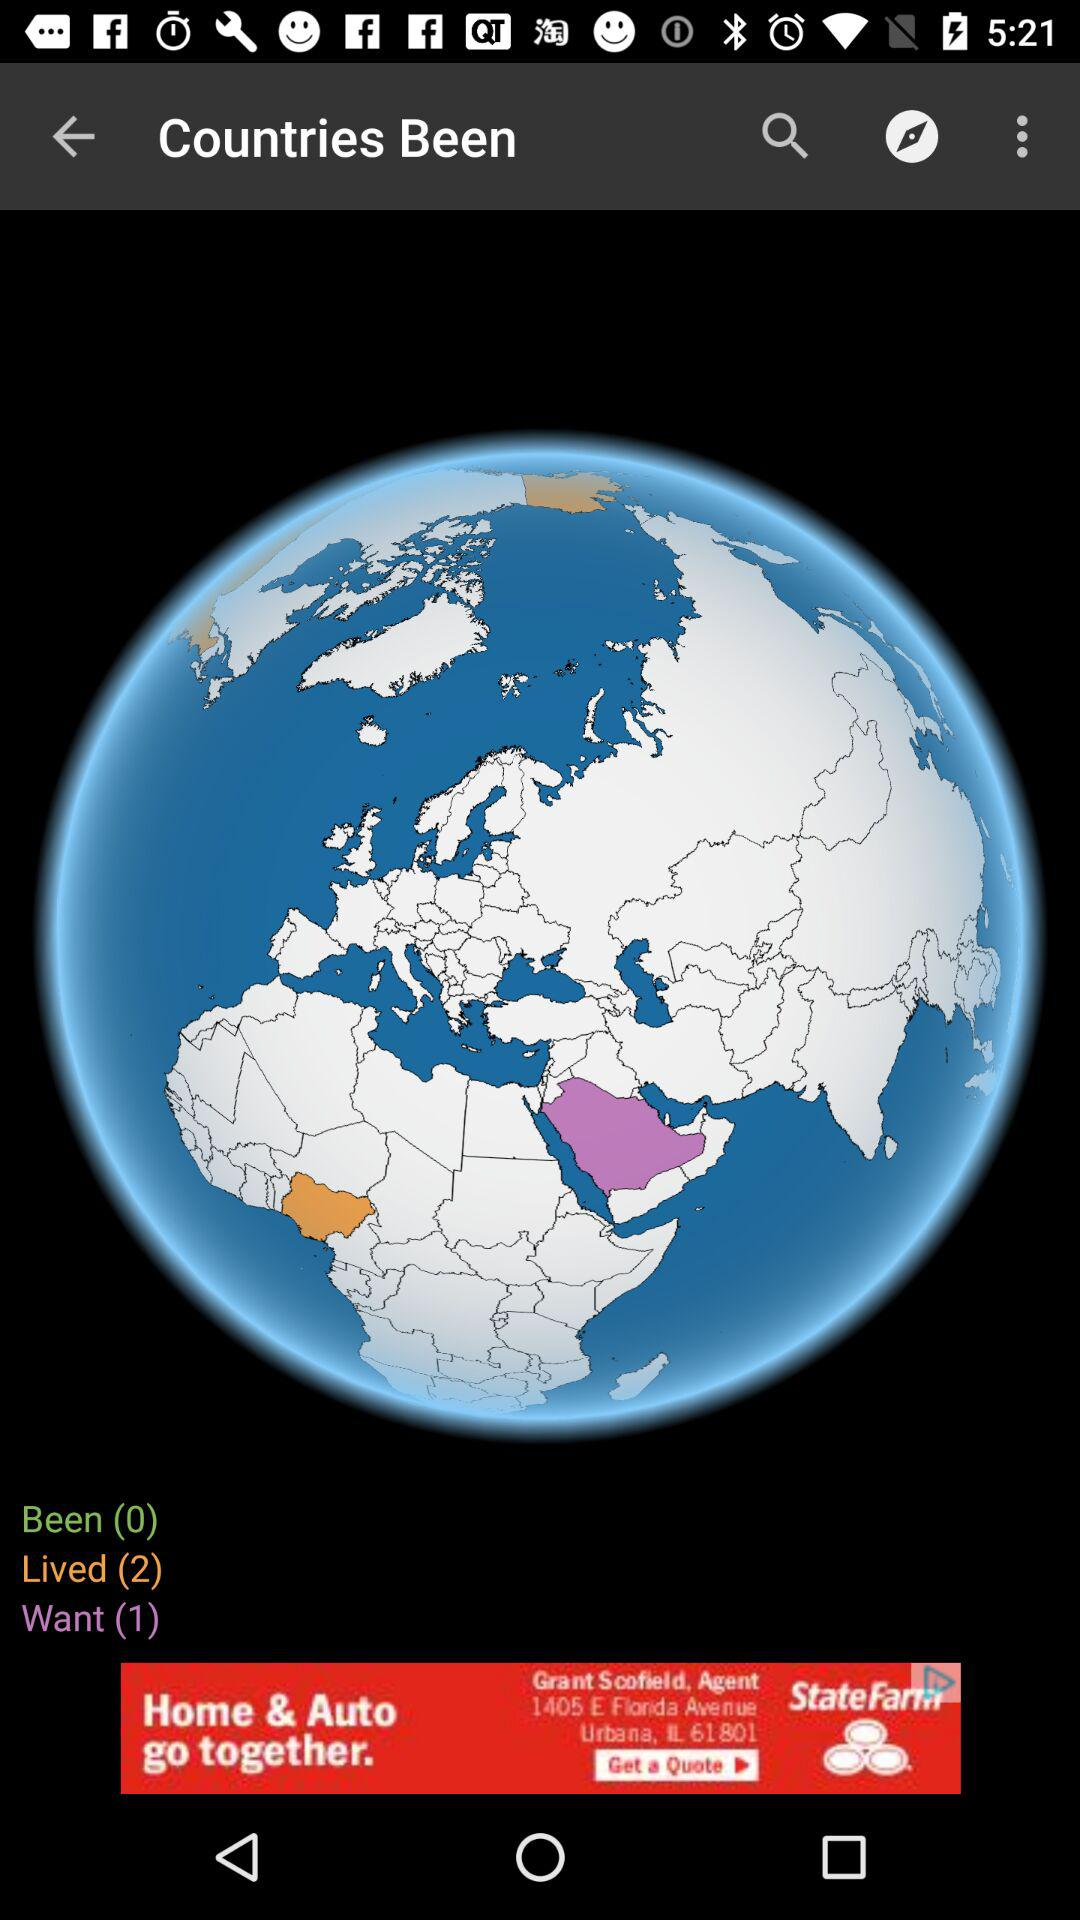How many more countries do I want to visit than have visited?
Answer the question using a single word or phrase. 1 